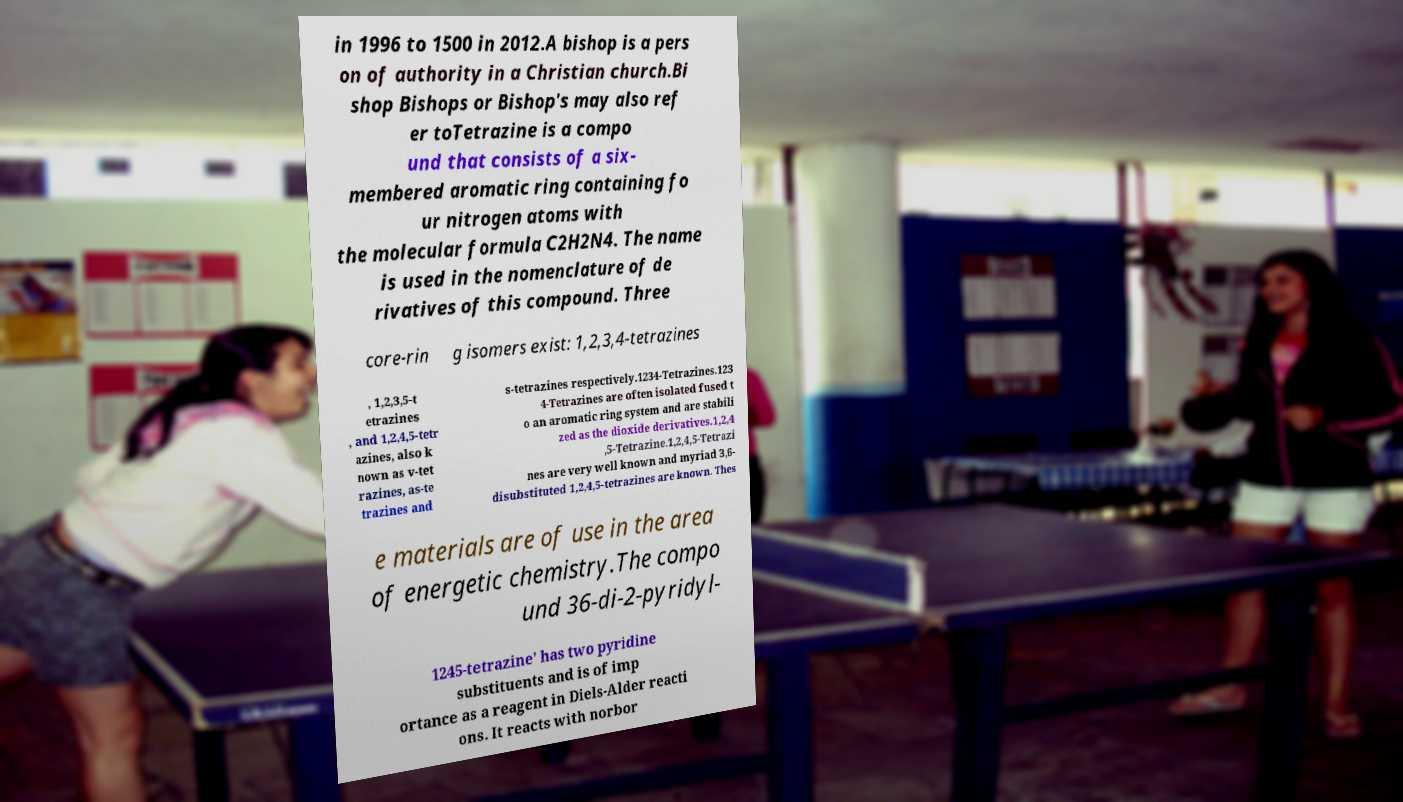Can you accurately transcribe the text from the provided image for me? in 1996 to 1500 in 2012.A bishop is a pers on of authority in a Christian church.Bi shop Bishops or Bishop's may also ref er toTetrazine is a compo und that consists of a six- membered aromatic ring containing fo ur nitrogen atoms with the molecular formula C2H2N4. The name is used in the nomenclature of de rivatives of this compound. Three core-rin g isomers exist: 1,2,3,4-tetrazines , 1,2,3,5-t etrazines , and 1,2,4,5-tetr azines, also k nown as v-tet razines, as-te trazines and s-tetrazines respectively.1234-Tetrazines.123 4-Tetrazines are often isolated fused t o an aromatic ring system and are stabili zed as the dioxide derivatives.1,2,4 ,5-Tetrazine.1,2,4,5-Tetrazi nes are very well known and myriad 3,6- disubstituted 1,2,4,5-tetrazines are known. Thes e materials are of use in the area of energetic chemistry.The compo und 36-di-2-pyridyl- 1245-tetrazine' has two pyridine substituents and is of imp ortance as a reagent in Diels-Alder reacti ons. It reacts with norbor 